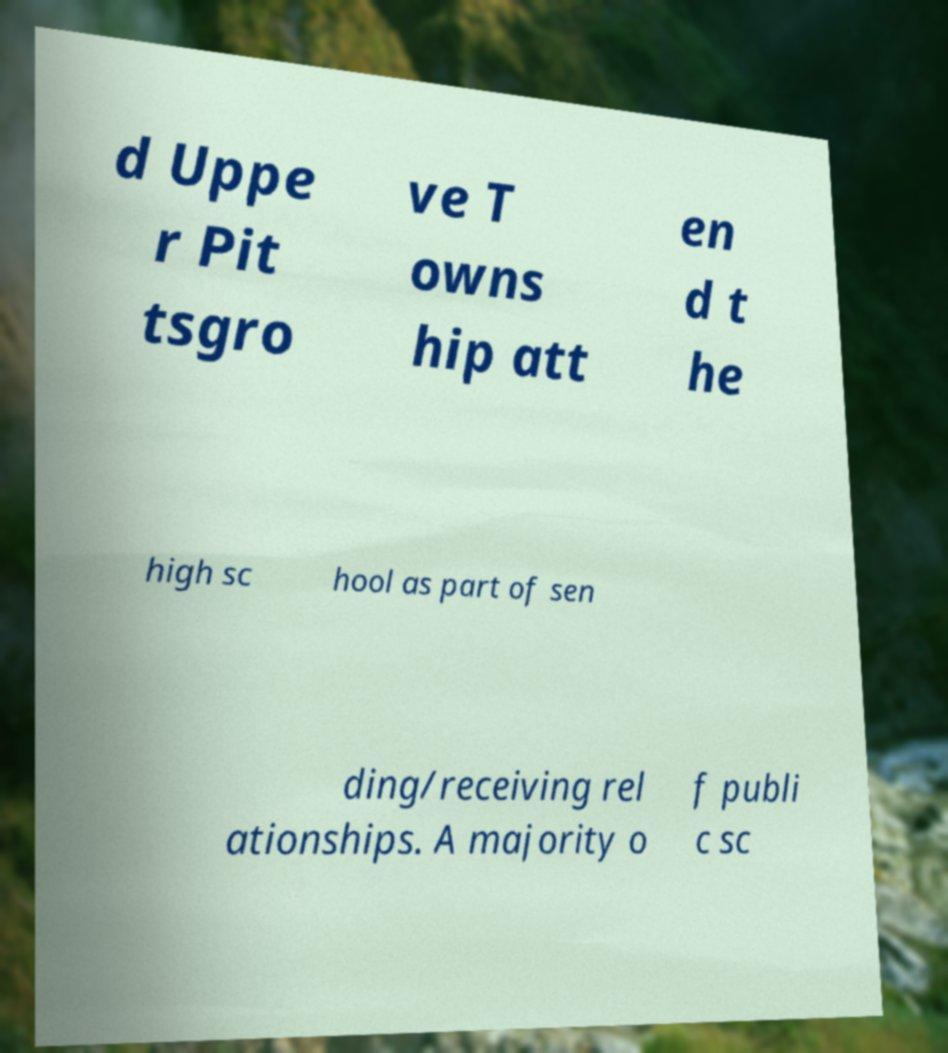For documentation purposes, I need the text within this image transcribed. Could you provide that? d Uppe r Pit tsgro ve T owns hip att en d t he high sc hool as part of sen ding/receiving rel ationships. A majority o f publi c sc 